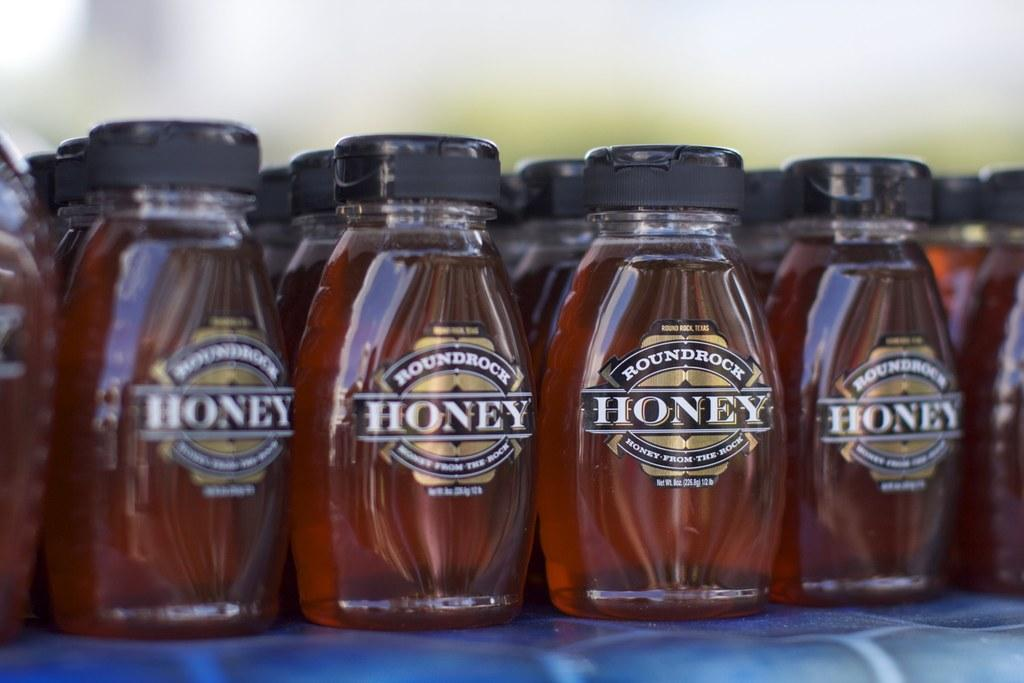<image>
Describe the image concisely. A bunch of bottles of honey on a table in the sun. 